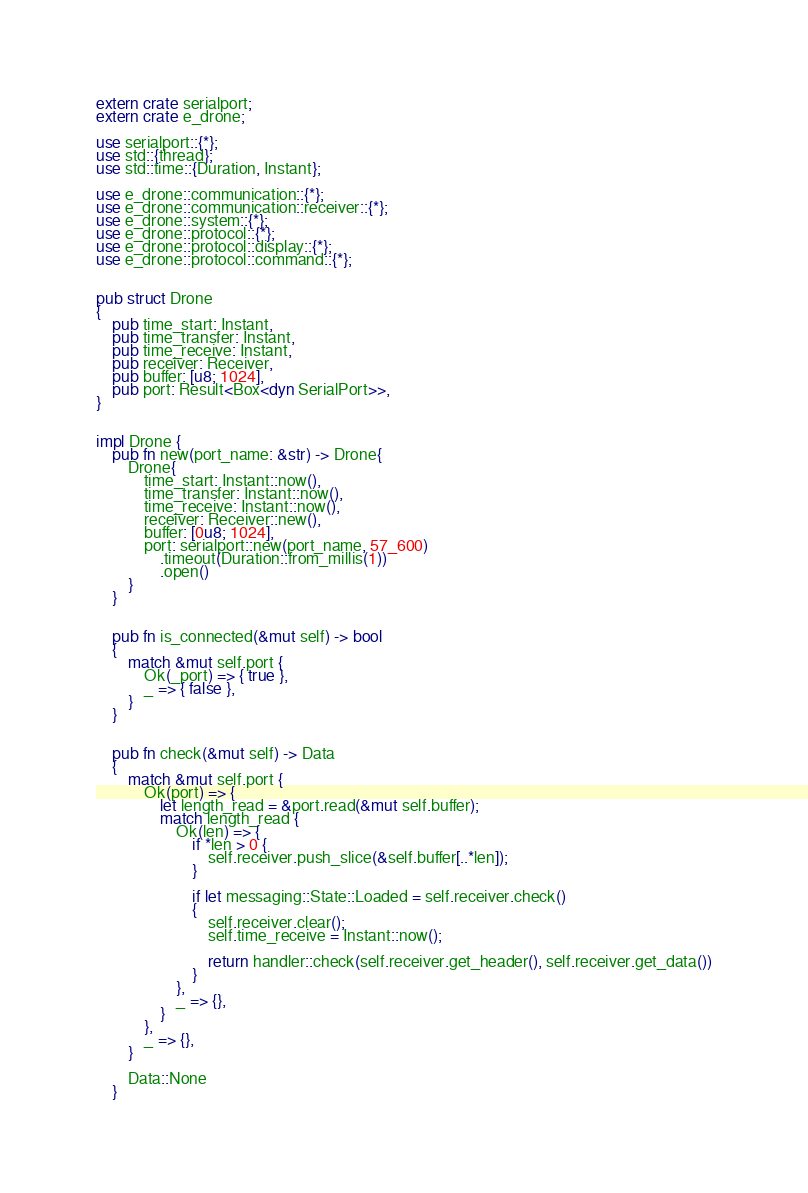<code> <loc_0><loc_0><loc_500><loc_500><_Rust_>extern crate serialport;
extern crate e_drone;

use serialport::{*};
use std::{thread};
use std::time::{Duration, Instant};

use e_drone::communication::{*};
use e_drone::communication::receiver::{*};
use e_drone::system::{*};
use e_drone::protocol::{*};
use e_drone::protocol::display::{*};
use e_drone::protocol::command::{*};


pub struct Drone
{
    pub time_start: Instant,
    pub time_transfer: Instant,
    pub time_receive: Instant,
    pub receiver: Receiver,
    pub buffer: [u8; 1024],
    pub port: Result<Box<dyn SerialPort>>,
}


impl Drone {
    pub fn new(port_name: &str) -> Drone{
        Drone{
            time_start: Instant::now(),
            time_transfer: Instant::now(),
            time_receive: Instant::now(),
            receiver: Receiver::new(),
            buffer: [0u8; 1024],
            port: serialport::new(port_name, 57_600)
                .timeout(Duration::from_millis(1))
                .open()
        }
    }


    pub fn is_connected(&mut self) -> bool
    {
        match &mut self.port {
            Ok(_port) => { true },
            _ => { false },
        }
    }


    pub fn check(&mut self) -> Data
    {
        match &mut self.port {
            Ok(port) => {
                let length_read = &port.read(&mut self.buffer);
                match length_read {
                    Ok(len) => {
                        if *len > 0 {
                            self.receiver.push_slice(&self.buffer[..*len]);
                        }

                        if let messaging::State::Loaded = self.receiver.check()
                        {
                            self.receiver.clear();
                            self.time_receive = Instant::now();

                            return handler::check(self.receiver.get_header(), self.receiver.get_data())
                        }
                    },
                    _ => {},
                }
            },
            _ => {},
        }

        Data::None
    }

</code> 